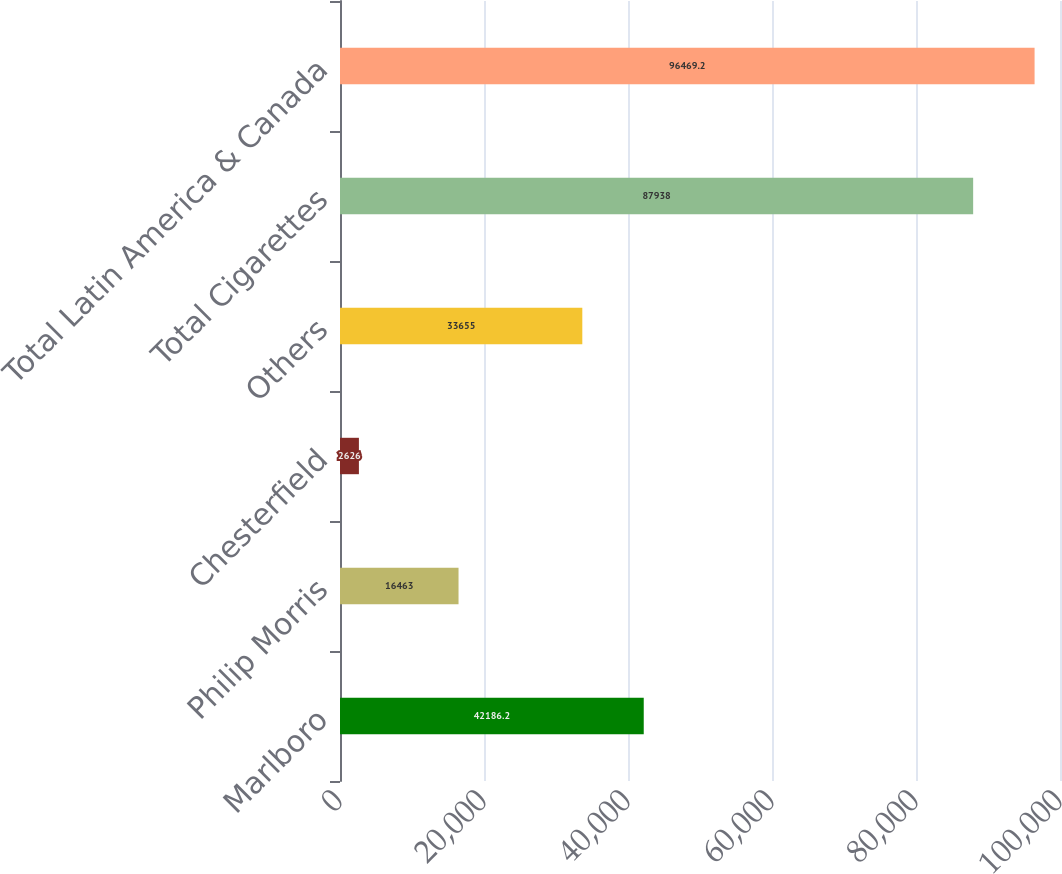Convert chart to OTSL. <chart><loc_0><loc_0><loc_500><loc_500><bar_chart><fcel>Marlboro<fcel>Philip Morris<fcel>Chesterfield<fcel>Others<fcel>Total Cigarettes<fcel>Total Latin America & Canada<nl><fcel>42186.2<fcel>16463<fcel>2626<fcel>33655<fcel>87938<fcel>96469.2<nl></chart> 